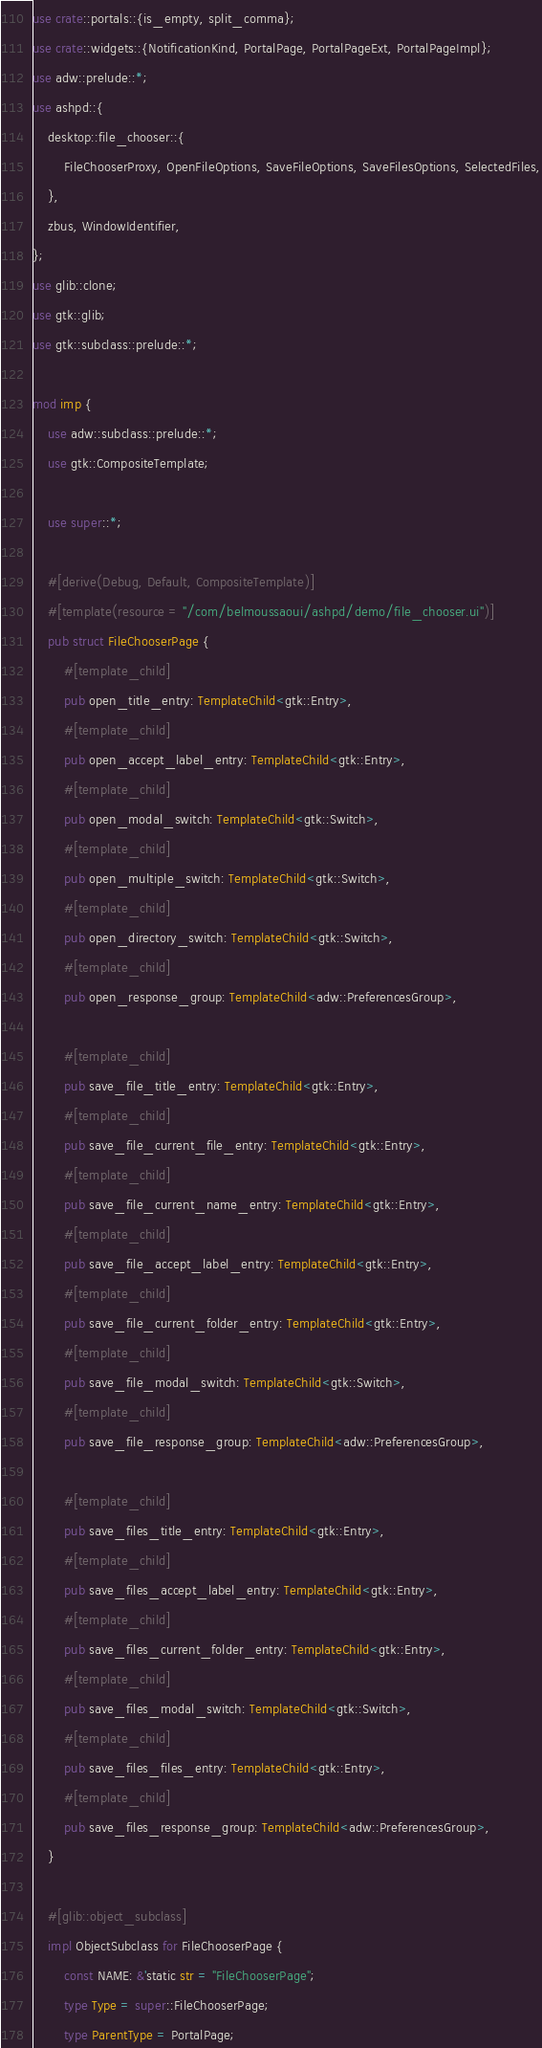<code> <loc_0><loc_0><loc_500><loc_500><_Rust_>use crate::portals::{is_empty, split_comma};
use crate::widgets::{NotificationKind, PortalPage, PortalPageExt, PortalPageImpl};
use adw::prelude::*;
use ashpd::{
    desktop::file_chooser::{
        FileChooserProxy, OpenFileOptions, SaveFileOptions, SaveFilesOptions, SelectedFiles,
    },
    zbus, WindowIdentifier,
};
use glib::clone;
use gtk::glib;
use gtk::subclass::prelude::*;

mod imp {
    use adw::subclass::prelude::*;
    use gtk::CompositeTemplate;

    use super::*;

    #[derive(Debug, Default, CompositeTemplate)]
    #[template(resource = "/com/belmoussaoui/ashpd/demo/file_chooser.ui")]
    pub struct FileChooserPage {
        #[template_child]
        pub open_title_entry: TemplateChild<gtk::Entry>,
        #[template_child]
        pub open_accept_label_entry: TemplateChild<gtk::Entry>,
        #[template_child]
        pub open_modal_switch: TemplateChild<gtk::Switch>,
        #[template_child]
        pub open_multiple_switch: TemplateChild<gtk::Switch>,
        #[template_child]
        pub open_directory_switch: TemplateChild<gtk::Switch>,
        #[template_child]
        pub open_response_group: TemplateChild<adw::PreferencesGroup>,

        #[template_child]
        pub save_file_title_entry: TemplateChild<gtk::Entry>,
        #[template_child]
        pub save_file_current_file_entry: TemplateChild<gtk::Entry>,
        #[template_child]
        pub save_file_current_name_entry: TemplateChild<gtk::Entry>,
        #[template_child]
        pub save_file_accept_label_entry: TemplateChild<gtk::Entry>,
        #[template_child]
        pub save_file_current_folder_entry: TemplateChild<gtk::Entry>,
        #[template_child]
        pub save_file_modal_switch: TemplateChild<gtk::Switch>,
        #[template_child]
        pub save_file_response_group: TemplateChild<adw::PreferencesGroup>,

        #[template_child]
        pub save_files_title_entry: TemplateChild<gtk::Entry>,
        #[template_child]
        pub save_files_accept_label_entry: TemplateChild<gtk::Entry>,
        #[template_child]
        pub save_files_current_folder_entry: TemplateChild<gtk::Entry>,
        #[template_child]
        pub save_files_modal_switch: TemplateChild<gtk::Switch>,
        #[template_child]
        pub save_files_files_entry: TemplateChild<gtk::Entry>,
        #[template_child]
        pub save_files_response_group: TemplateChild<adw::PreferencesGroup>,
    }

    #[glib::object_subclass]
    impl ObjectSubclass for FileChooserPage {
        const NAME: &'static str = "FileChooserPage";
        type Type = super::FileChooserPage;
        type ParentType = PortalPage;
</code> 